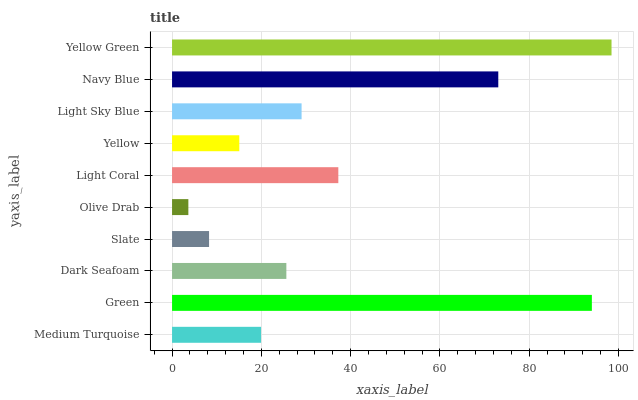Is Olive Drab the minimum?
Answer yes or no. Yes. Is Yellow Green the maximum?
Answer yes or no. Yes. Is Green the minimum?
Answer yes or no. No. Is Green the maximum?
Answer yes or no. No. Is Green greater than Medium Turquoise?
Answer yes or no. Yes. Is Medium Turquoise less than Green?
Answer yes or no. Yes. Is Medium Turquoise greater than Green?
Answer yes or no. No. Is Green less than Medium Turquoise?
Answer yes or no. No. Is Light Sky Blue the high median?
Answer yes or no. Yes. Is Dark Seafoam the low median?
Answer yes or no. Yes. Is Yellow Green the high median?
Answer yes or no. No. Is Medium Turquoise the low median?
Answer yes or no. No. 